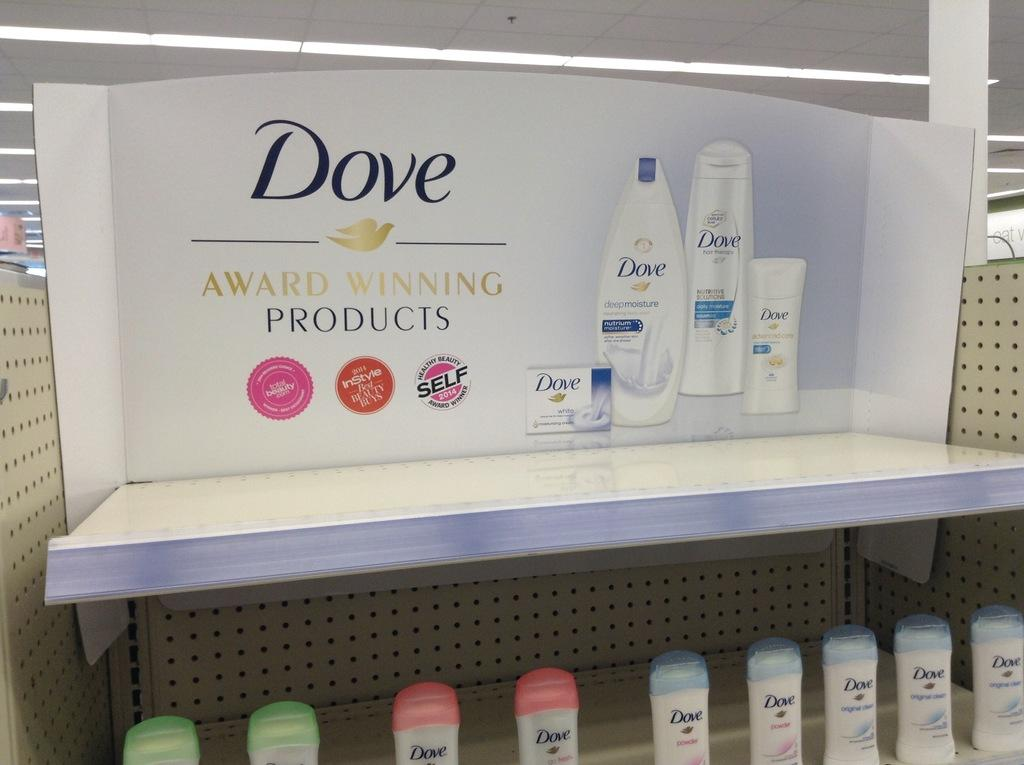<image>
Offer a succinct explanation of the picture presented. a display case for Dove Award Winning Products in a store 